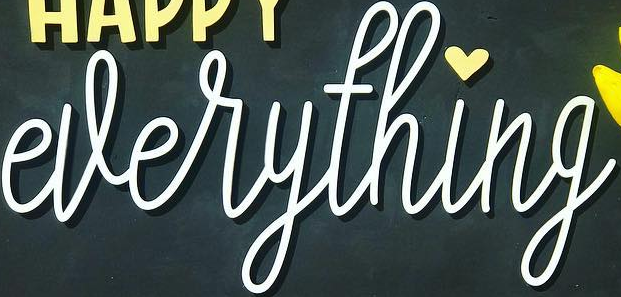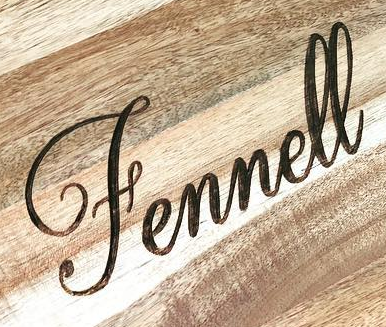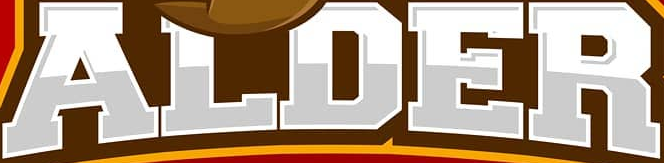What text appears in these images from left to right, separated by a semicolon? everything; Fennell; ALDER 